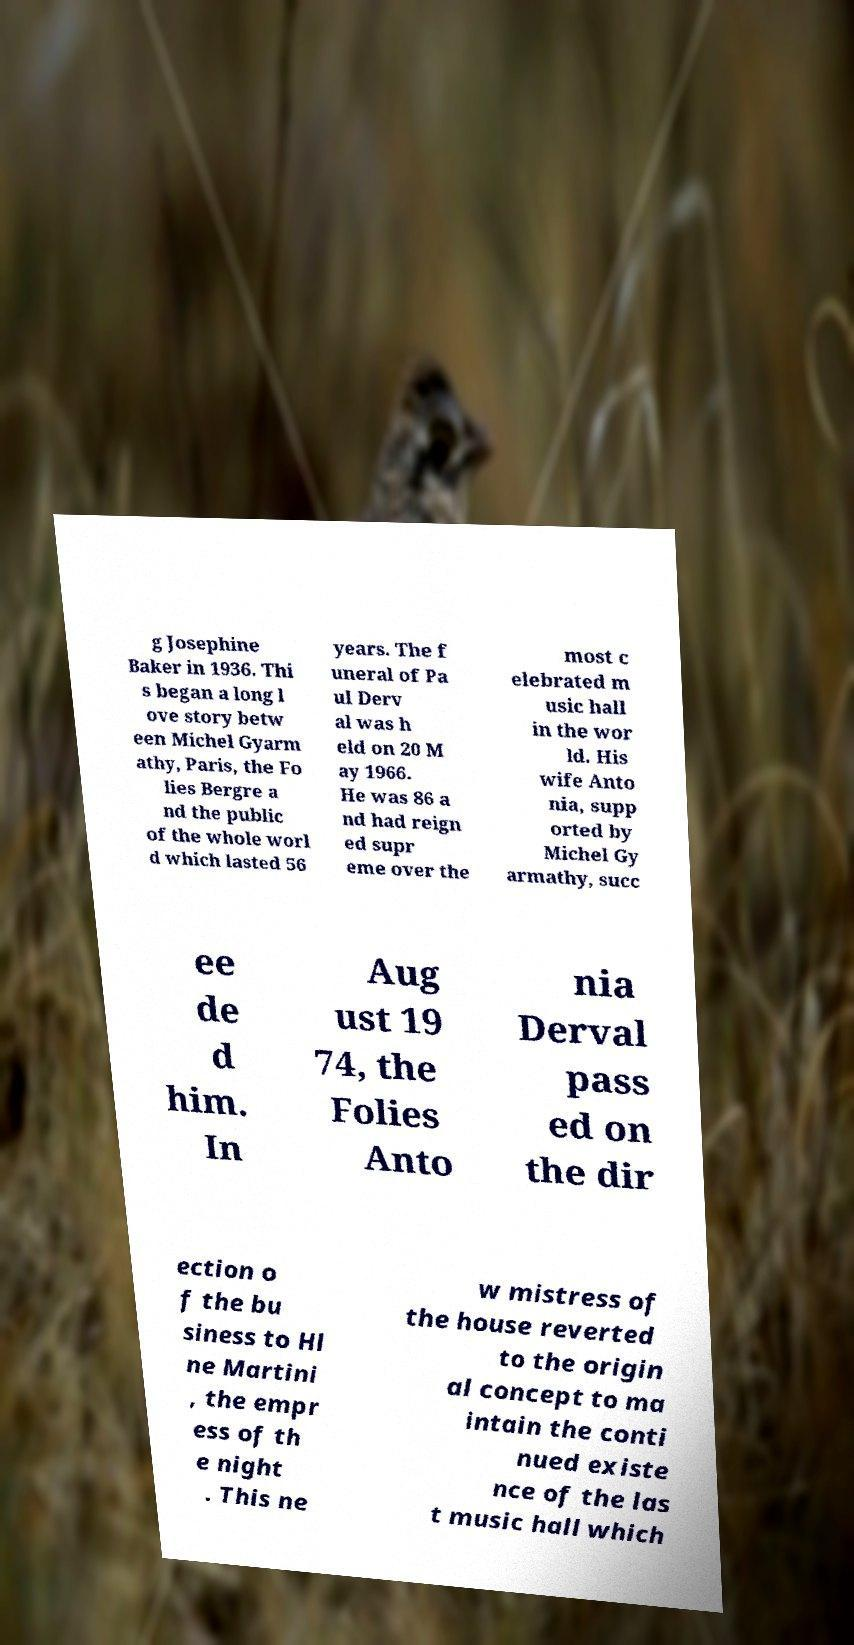Could you assist in decoding the text presented in this image and type it out clearly? g Josephine Baker in 1936. Thi s began a long l ove story betw een Michel Gyarm athy, Paris, the Fo lies Bergre a nd the public of the whole worl d which lasted 56 years. The f uneral of Pa ul Derv al was h eld on 20 M ay 1966. He was 86 a nd had reign ed supr eme over the most c elebrated m usic hall in the wor ld. His wife Anto nia, supp orted by Michel Gy armathy, succ ee de d him. In Aug ust 19 74, the Folies Anto nia Derval pass ed on the dir ection o f the bu siness to Hl ne Martini , the empr ess of th e night . This ne w mistress of the house reverted to the origin al concept to ma intain the conti nued existe nce of the las t music hall which 